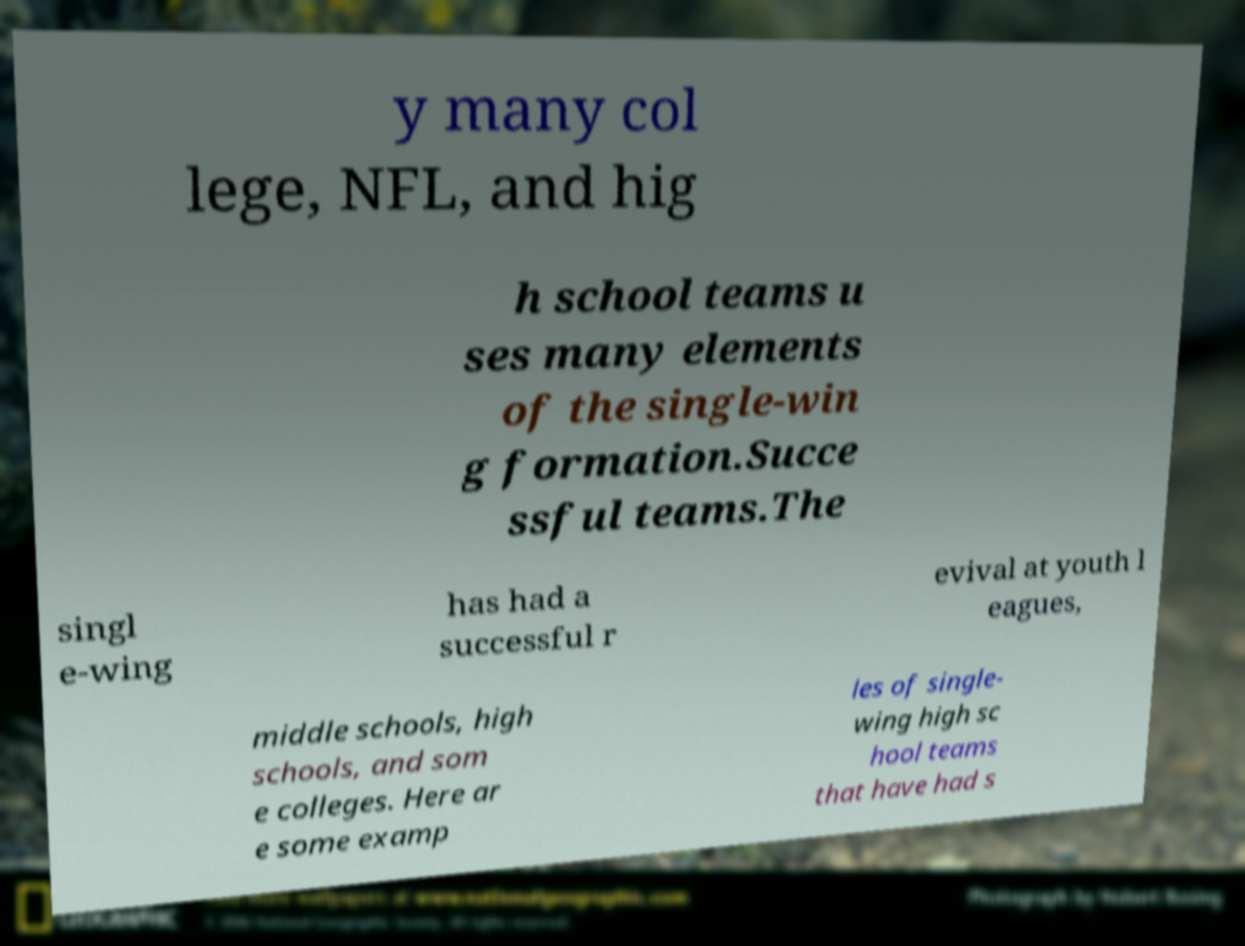What messages or text are displayed in this image? I need them in a readable, typed format. y many col lege, NFL, and hig h school teams u ses many elements of the single-win g formation.Succe ssful teams.The singl e-wing has had a successful r evival at youth l eagues, middle schools, high schools, and som e colleges. Here ar e some examp les of single- wing high sc hool teams that have had s 